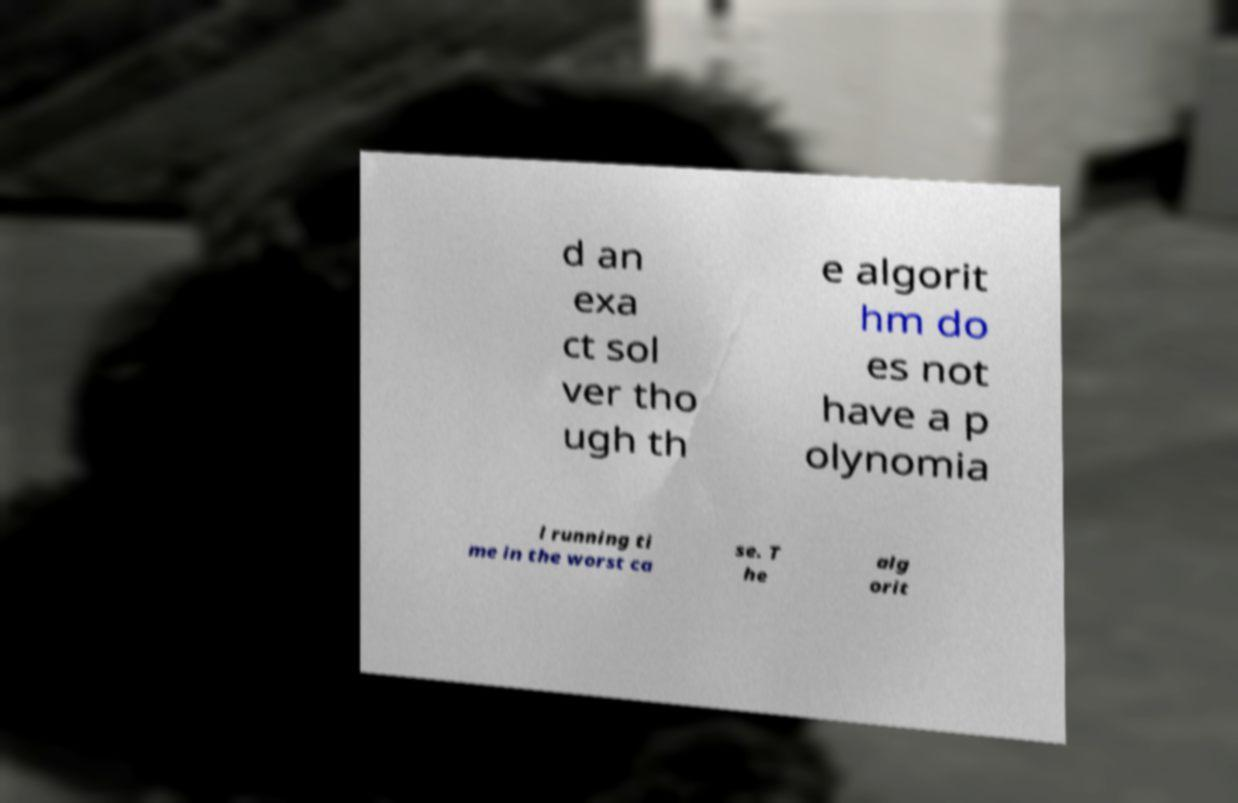Can you read and provide the text displayed in the image?This photo seems to have some interesting text. Can you extract and type it out for me? d an exa ct sol ver tho ugh th e algorit hm do es not have a p olynomia l running ti me in the worst ca se. T he alg orit 